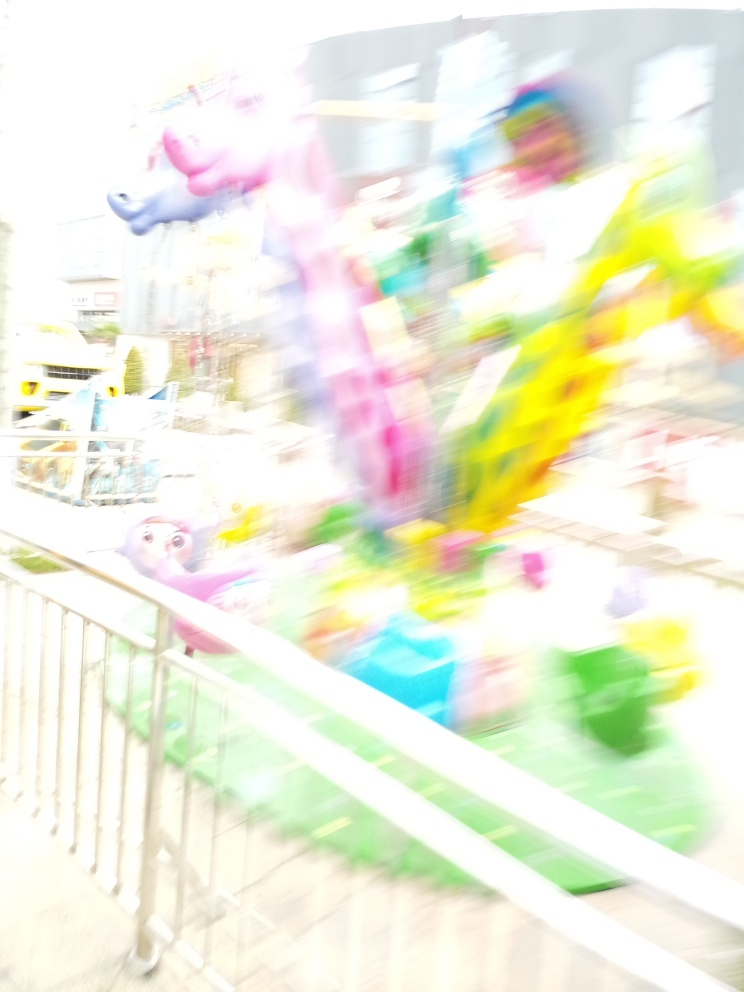What does the blurriness add to the picture? The blurriness adds a sense of movement and liveliness to the picture. It portrays a fleeting moment in time, perhaps in a busy and energetic setting, where the subjects are in constant motion, creating an abstract and artistic impression rather than a static and sharp depiction. 